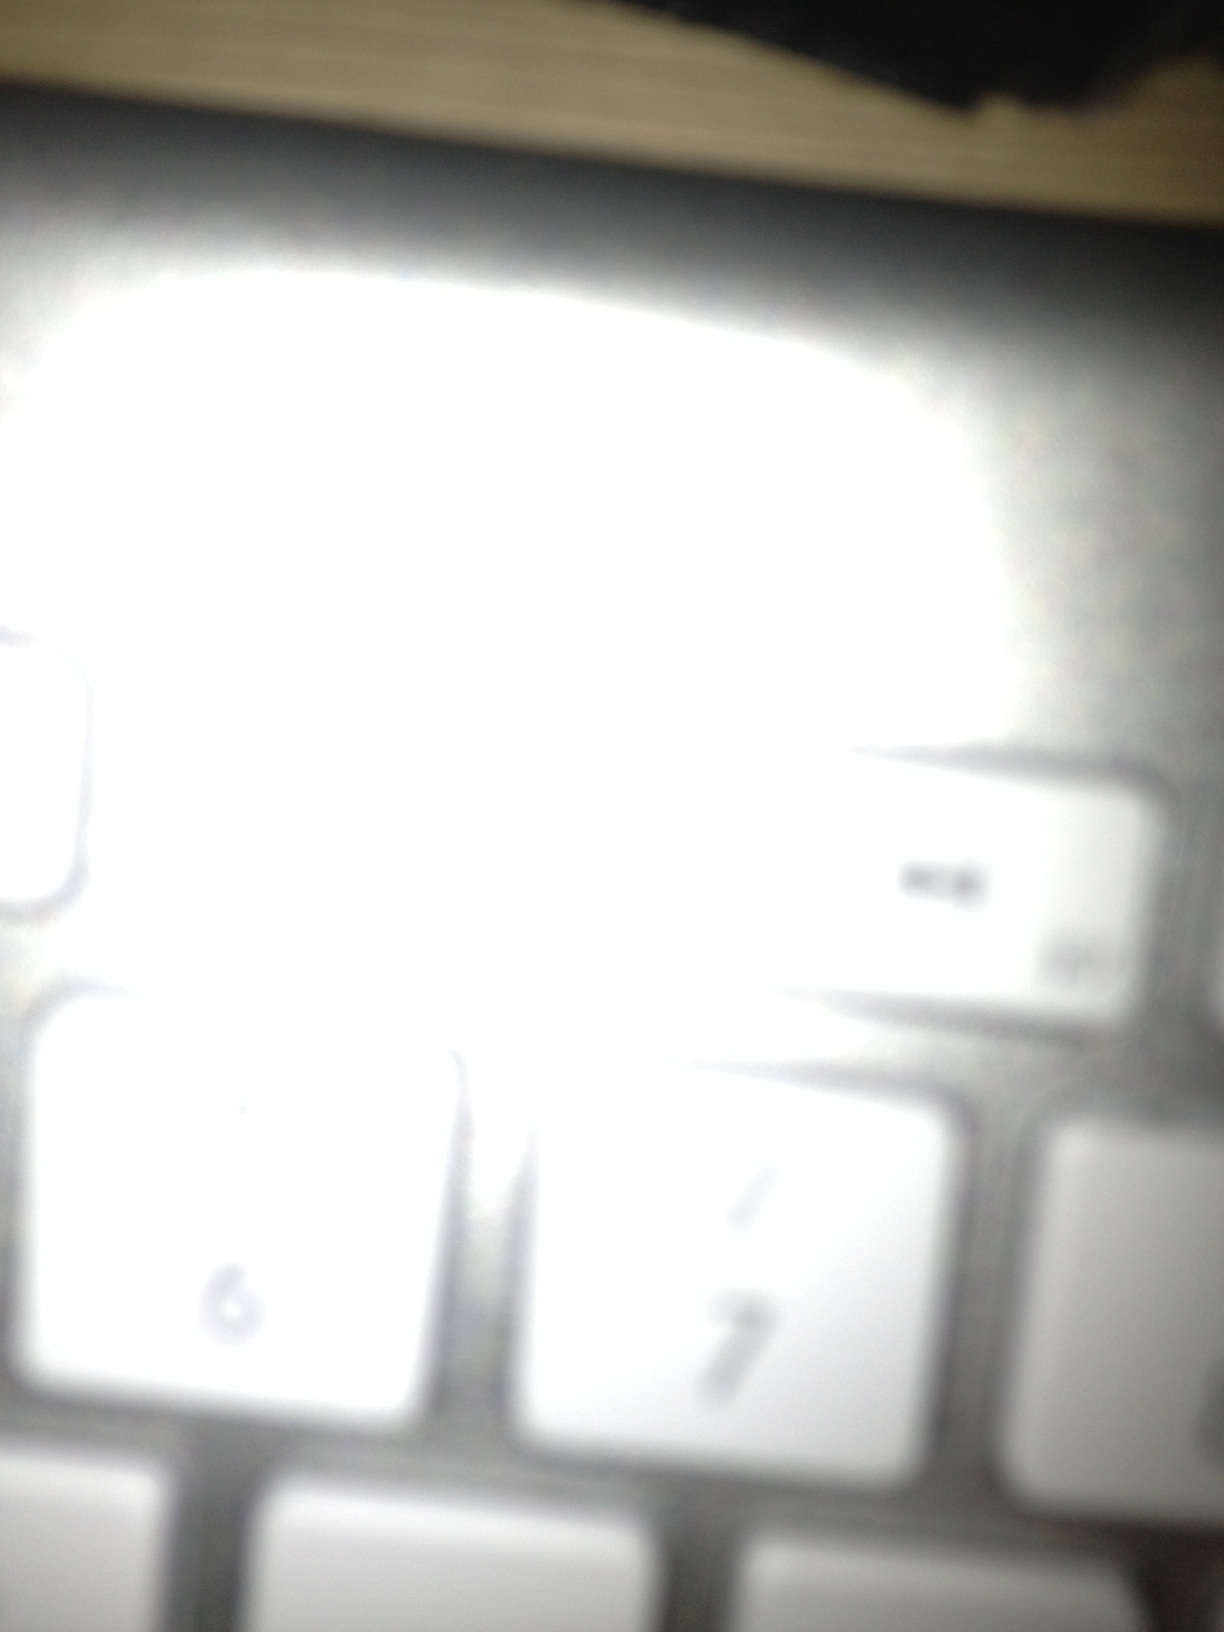Can you describe what you see in detail? The image appears to show a section of a keyboard. Specifically, it includes a close-up of the number keys, with 6 and 7 being the most prominent. The image is quite blurry and overexposed, making it difficult to see clear details, but the basic layout and the shape of the keys suggest it is from a standard keyboard. Do you think there is anything unusual about this keyboard? Given the quality of the image, it is hard to ascertain if there is anything particularly unusual about this keyboard. It appears to be a standard keyboard, but the blur and overexposure do make it look somewhat out of the ordinary. What could have caused the blurry and overexposed image? The blurriness and overexposure could have been caused by a few factors. The camera might have been too close to the keyboard, resulting in an out-of-focus shot. Additionally, there might have been excessive light or a flash that caused the overexposure, washing out the finer details of the keys. 